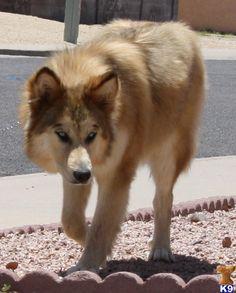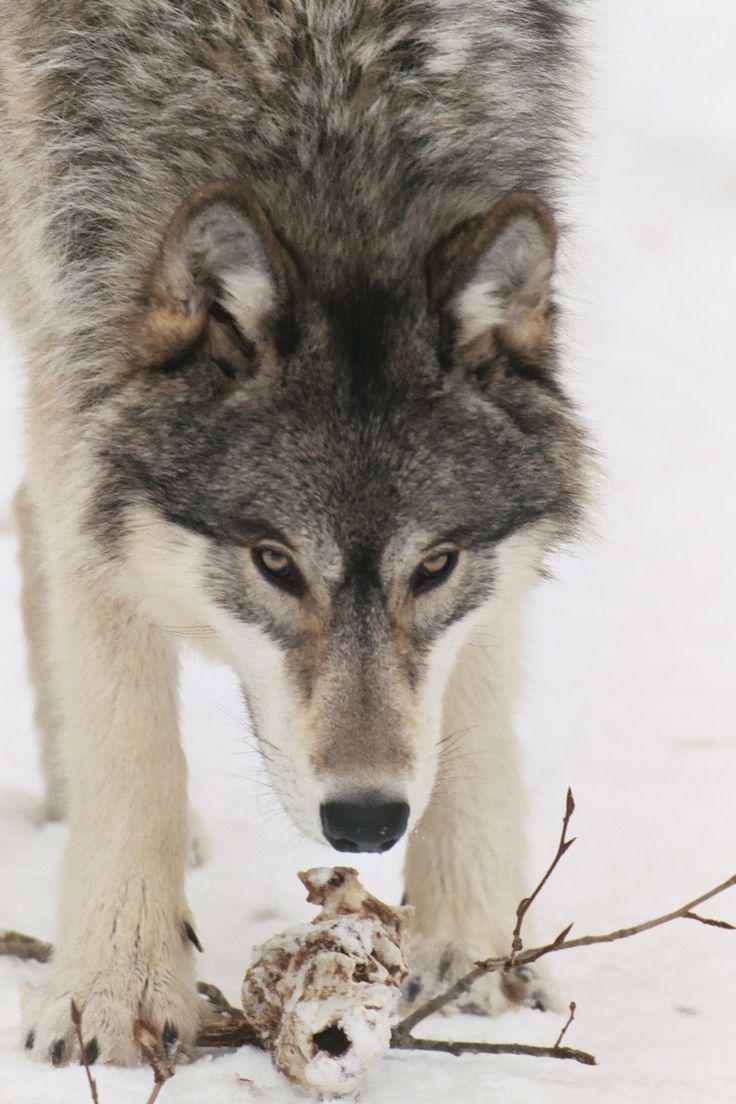The first image is the image on the left, the second image is the image on the right. Analyze the images presented: Is the assertion "Two animals have their tongues out." valid? Answer yes or no. No. The first image is the image on the left, the second image is the image on the right. Analyze the images presented: Is the assertion "The left image shows a single adult, wolf with one front paw off the ground and its head somewhat lowered and facing forward." valid? Answer yes or no. Yes. 